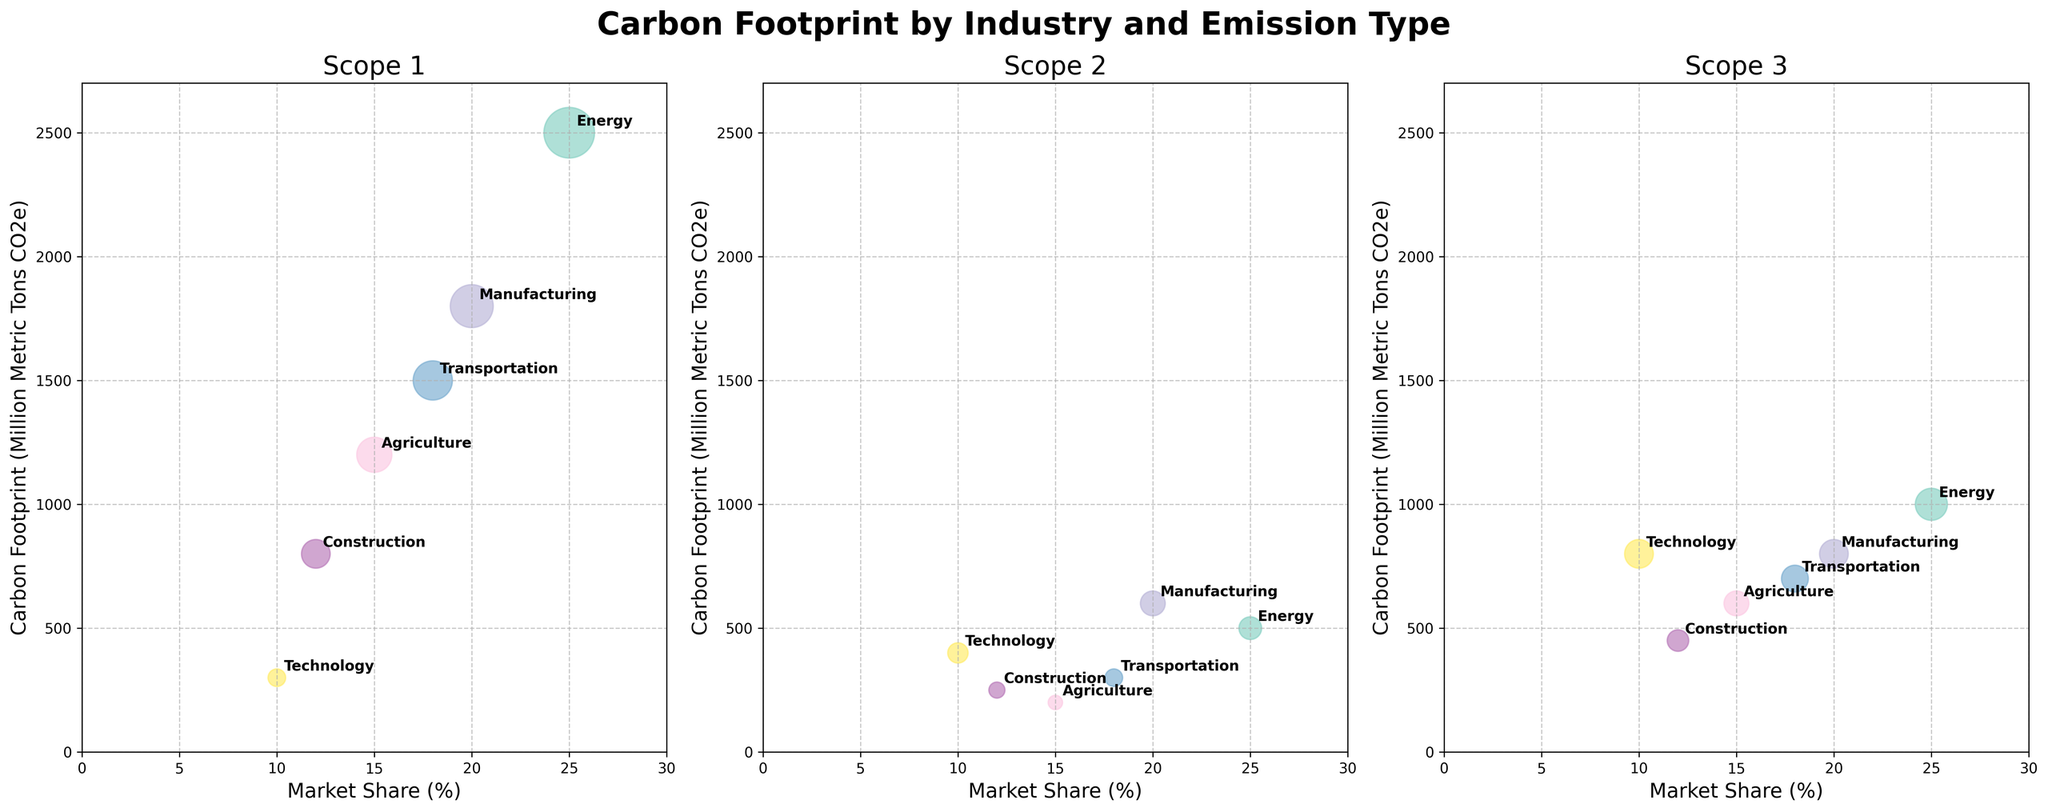What's the title of the plot? The title of the plot is usually placed at the top and provides a summary of what the plot is about. In this case, it states "Carbon Footprint by Industry and Emission Type".
Answer: Carbon Footprint by Industry and Emission Type How many subplots are there in the figure? Subplots are separate smaller plots within the main figure. By observing the figure, we can see there are three distinct subplots each for different emission types.
Answer: 3 Which industry has the highest carbon footprint in Scope 1 emissions? In the subplot for Scope 1 emissions, the bubble for the "Energy" industry is the largest and positioned highest on the y-axis, indicating the highest carbon footprint.
Answer: Energy What are the x and y-axis labels in the subplots? Axis labels provide context for understanding the data represented on each axis. In this figure, the x-axis label is "Market Share (%)" and the y-axis label is "Carbon Footprint (Million Metric Tons CO2e)".
Answer: x-axis: Market Share (%), y-axis: Carbon Footprint (Million Metric Tons CO2e) How does the carbon footprint of the Technology industry compare between Scope 1 and Scope 3 emissions? By observing the subplots for Scope 1 and Scope 3 emissions, we can see that the "Technology" industry has a significantly larger carbon footprint in Scope 3 (800) compared to Scope 1 (300).
Answer: Scope 3 is larger than Scope 1 Which two industries have the closest carbon footprints in Scope 2 emissions? In the subplot for Scope 2 emissions, examining the positions and sizes of the bubbles, "Manufacturing" (600) and "Technology" (400) have the closest carbon footprints.
Answer: Manufacturing and Technology What is the carbon footprint of the Agriculture industry for Scope 2 emissions? In the subplot for Scope 2 emissions, find the bubble representing the "Agriculture" industry. The y-axis position indicates this value, which is 200 million metric tons CO2e.
Answer: 200 Compare the market shares of the Transportation and Construction industries. Which one is greater and by how much? Compare the x-axis values from all subplots for Transportation (18%) and Construction (12%). Calculation: 18% - 12% = 6%. Transportation has a greater market share by 6%.
Answer: Transportation by 6% How many industries have their carbon footprint displayed in each subplot? For each subplot, count the bubbles representing different industries. Each subplot consistently displays bubbles for six industries.
Answer: 6 What is the total carbon footprint of the Manufacturing industry across all emission scopes? Sum the carbon footprints of the Manufacturing industry from each emission scope: Scope 1 (1800) + Scope 2 (600) + Scope 3 (800) = 3200 million metric tons CO2e.
Answer: 3200 